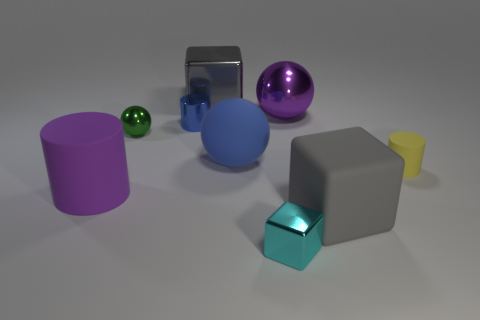Which objects in the image could be used to store a small amount of liquid? The yellow cone, resembling a cup, could potentially hold a small amount of liquid. 